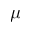<formula> <loc_0><loc_0><loc_500><loc_500>\mu</formula> 